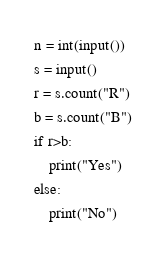Convert code to text. <code><loc_0><loc_0><loc_500><loc_500><_Python_>n = int(input())
s = input()
r = s.count("R")
b = s.count("B")
if r>b:
    print("Yes")
else:
    print("No")
</code> 